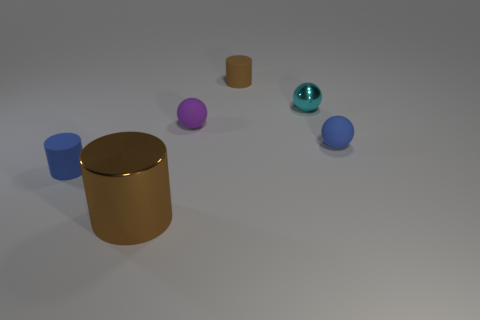Add 2 gray cubes. How many objects exist? 8 Subtract 0 cyan cubes. How many objects are left? 6 Subtract all big brown shiny things. Subtract all big brown cylinders. How many objects are left? 4 Add 4 brown things. How many brown things are left? 6 Add 5 big cylinders. How many big cylinders exist? 6 